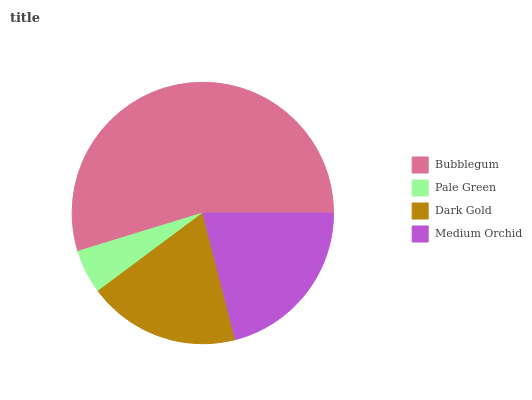Is Pale Green the minimum?
Answer yes or no. Yes. Is Bubblegum the maximum?
Answer yes or no. Yes. Is Dark Gold the minimum?
Answer yes or no. No. Is Dark Gold the maximum?
Answer yes or no. No. Is Dark Gold greater than Pale Green?
Answer yes or no. Yes. Is Pale Green less than Dark Gold?
Answer yes or no. Yes. Is Pale Green greater than Dark Gold?
Answer yes or no. No. Is Dark Gold less than Pale Green?
Answer yes or no. No. Is Medium Orchid the high median?
Answer yes or no. Yes. Is Dark Gold the low median?
Answer yes or no. Yes. Is Dark Gold the high median?
Answer yes or no. No. Is Medium Orchid the low median?
Answer yes or no. No. 